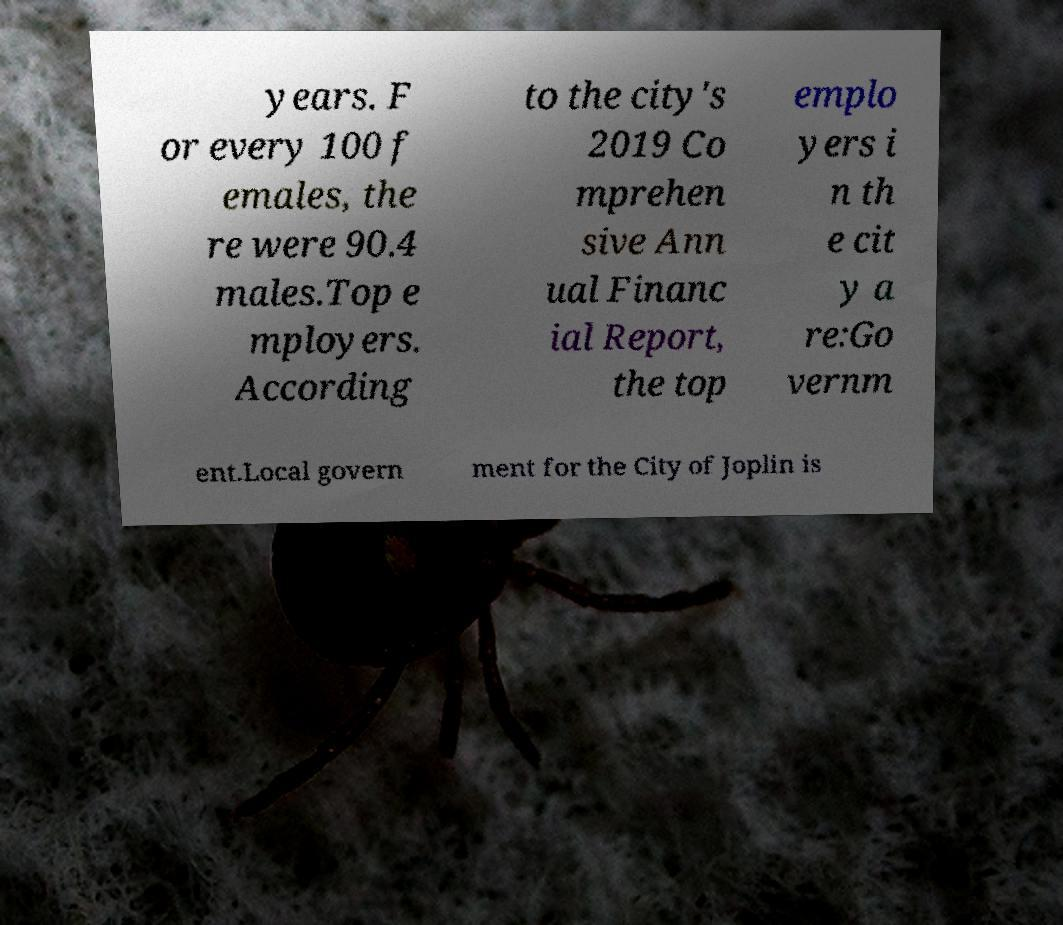Please read and relay the text visible in this image. What does it say? years. F or every 100 f emales, the re were 90.4 males.Top e mployers. According to the city's 2019 Co mprehen sive Ann ual Financ ial Report, the top emplo yers i n th e cit y a re:Go vernm ent.Local govern ment for the City of Joplin is 